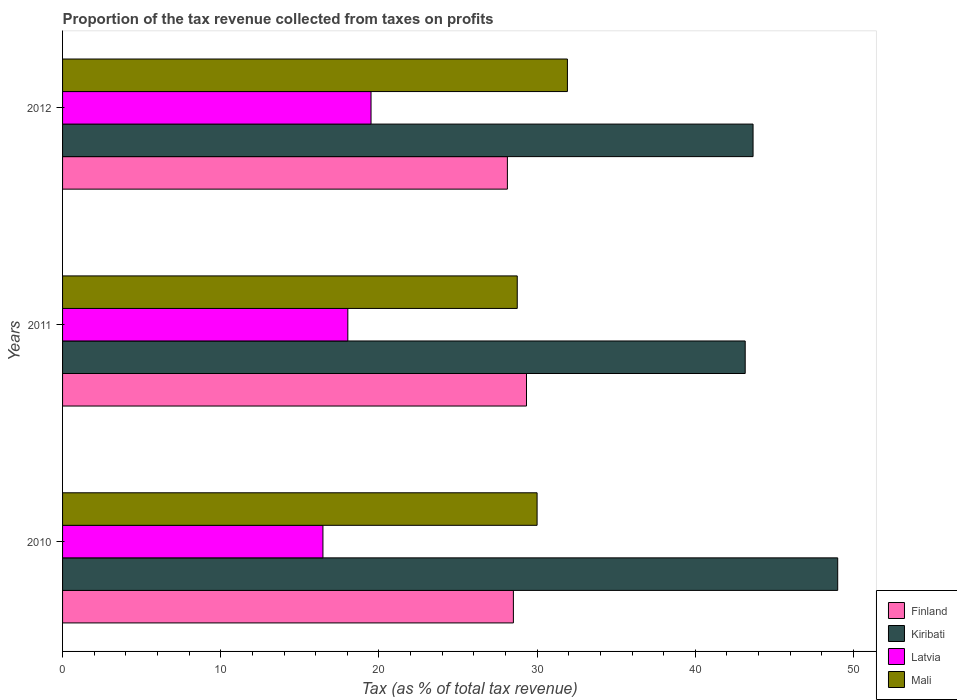How many groups of bars are there?
Provide a succinct answer. 3. How many bars are there on the 3rd tick from the top?
Provide a short and direct response. 4. What is the label of the 1st group of bars from the top?
Give a very brief answer. 2012. What is the proportion of the tax revenue collected in Latvia in 2010?
Offer a terse response. 16.46. Across all years, what is the maximum proportion of the tax revenue collected in Mali?
Offer a very short reply. 31.92. Across all years, what is the minimum proportion of the tax revenue collected in Finland?
Keep it short and to the point. 28.12. In which year was the proportion of the tax revenue collected in Finland maximum?
Your answer should be compact. 2011. In which year was the proportion of the tax revenue collected in Latvia minimum?
Offer a terse response. 2010. What is the total proportion of the tax revenue collected in Mali in the graph?
Make the answer very short. 90.66. What is the difference between the proportion of the tax revenue collected in Latvia in 2010 and that in 2011?
Provide a succinct answer. -1.57. What is the difference between the proportion of the tax revenue collected in Latvia in 2010 and the proportion of the tax revenue collected in Mali in 2012?
Your answer should be very brief. -15.46. What is the average proportion of the tax revenue collected in Finland per year?
Make the answer very short. 28.65. In the year 2011, what is the difference between the proportion of the tax revenue collected in Finland and proportion of the tax revenue collected in Kiribati?
Provide a succinct answer. -13.83. What is the ratio of the proportion of the tax revenue collected in Latvia in 2010 to that in 2011?
Your answer should be compact. 0.91. What is the difference between the highest and the second highest proportion of the tax revenue collected in Mali?
Offer a terse response. 1.92. What is the difference between the highest and the lowest proportion of the tax revenue collected in Finland?
Your answer should be compact. 1.21. In how many years, is the proportion of the tax revenue collected in Kiribati greater than the average proportion of the tax revenue collected in Kiribati taken over all years?
Your response must be concise. 1. Is the sum of the proportion of the tax revenue collected in Kiribati in 2011 and 2012 greater than the maximum proportion of the tax revenue collected in Mali across all years?
Your answer should be very brief. Yes. Is it the case that in every year, the sum of the proportion of the tax revenue collected in Kiribati and proportion of the tax revenue collected in Latvia is greater than the sum of proportion of the tax revenue collected in Mali and proportion of the tax revenue collected in Finland?
Offer a terse response. No. What does the 4th bar from the top in 2012 represents?
Your answer should be very brief. Finland. What does the 2nd bar from the bottom in 2010 represents?
Provide a short and direct response. Kiribati. Is it the case that in every year, the sum of the proportion of the tax revenue collected in Finland and proportion of the tax revenue collected in Kiribati is greater than the proportion of the tax revenue collected in Mali?
Your response must be concise. Yes. How many bars are there?
Your response must be concise. 12. Are all the bars in the graph horizontal?
Your response must be concise. Yes. What is the difference between two consecutive major ticks on the X-axis?
Keep it short and to the point. 10. Does the graph contain any zero values?
Your response must be concise. No. How are the legend labels stacked?
Your response must be concise. Vertical. What is the title of the graph?
Your answer should be very brief. Proportion of the tax revenue collected from taxes on profits. Does "Aruba" appear as one of the legend labels in the graph?
Provide a succinct answer. No. What is the label or title of the X-axis?
Provide a short and direct response. Tax (as % of total tax revenue). What is the label or title of the Y-axis?
Provide a short and direct response. Years. What is the Tax (as % of total tax revenue) of Finland in 2010?
Provide a succinct answer. 28.5. What is the Tax (as % of total tax revenue) of Kiribati in 2010?
Make the answer very short. 49. What is the Tax (as % of total tax revenue) in Latvia in 2010?
Your answer should be compact. 16.46. What is the Tax (as % of total tax revenue) of Mali in 2010?
Your answer should be very brief. 30. What is the Tax (as % of total tax revenue) of Finland in 2011?
Keep it short and to the point. 29.33. What is the Tax (as % of total tax revenue) in Kiribati in 2011?
Keep it short and to the point. 43.16. What is the Tax (as % of total tax revenue) in Latvia in 2011?
Offer a terse response. 18.03. What is the Tax (as % of total tax revenue) in Mali in 2011?
Your response must be concise. 28.75. What is the Tax (as % of total tax revenue) of Finland in 2012?
Offer a very short reply. 28.12. What is the Tax (as % of total tax revenue) of Kiribati in 2012?
Provide a succinct answer. 43.65. What is the Tax (as % of total tax revenue) of Latvia in 2012?
Make the answer very short. 19.5. What is the Tax (as % of total tax revenue) of Mali in 2012?
Your answer should be very brief. 31.92. Across all years, what is the maximum Tax (as % of total tax revenue) of Finland?
Keep it short and to the point. 29.33. Across all years, what is the maximum Tax (as % of total tax revenue) of Kiribati?
Provide a succinct answer. 49. Across all years, what is the maximum Tax (as % of total tax revenue) in Latvia?
Ensure brevity in your answer.  19.5. Across all years, what is the maximum Tax (as % of total tax revenue) of Mali?
Provide a succinct answer. 31.92. Across all years, what is the minimum Tax (as % of total tax revenue) of Finland?
Your answer should be very brief. 28.12. Across all years, what is the minimum Tax (as % of total tax revenue) of Kiribati?
Offer a terse response. 43.16. Across all years, what is the minimum Tax (as % of total tax revenue) of Latvia?
Your response must be concise. 16.46. Across all years, what is the minimum Tax (as % of total tax revenue) of Mali?
Offer a very short reply. 28.75. What is the total Tax (as % of total tax revenue) of Finland in the graph?
Your response must be concise. 85.95. What is the total Tax (as % of total tax revenue) in Kiribati in the graph?
Ensure brevity in your answer.  135.81. What is the total Tax (as % of total tax revenue) of Latvia in the graph?
Offer a very short reply. 54. What is the total Tax (as % of total tax revenue) of Mali in the graph?
Keep it short and to the point. 90.66. What is the difference between the Tax (as % of total tax revenue) of Finland in 2010 and that in 2011?
Provide a succinct answer. -0.83. What is the difference between the Tax (as % of total tax revenue) in Kiribati in 2010 and that in 2011?
Provide a short and direct response. 5.85. What is the difference between the Tax (as % of total tax revenue) of Latvia in 2010 and that in 2011?
Your response must be concise. -1.57. What is the difference between the Tax (as % of total tax revenue) in Mali in 2010 and that in 2011?
Your answer should be very brief. 1.25. What is the difference between the Tax (as % of total tax revenue) in Finland in 2010 and that in 2012?
Your answer should be compact. 0.38. What is the difference between the Tax (as % of total tax revenue) in Kiribati in 2010 and that in 2012?
Your response must be concise. 5.35. What is the difference between the Tax (as % of total tax revenue) in Latvia in 2010 and that in 2012?
Your response must be concise. -3.04. What is the difference between the Tax (as % of total tax revenue) in Mali in 2010 and that in 2012?
Your answer should be very brief. -1.92. What is the difference between the Tax (as % of total tax revenue) of Finland in 2011 and that in 2012?
Offer a terse response. 1.21. What is the difference between the Tax (as % of total tax revenue) of Kiribati in 2011 and that in 2012?
Your response must be concise. -0.5. What is the difference between the Tax (as % of total tax revenue) in Latvia in 2011 and that in 2012?
Ensure brevity in your answer.  -1.47. What is the difference between the Tax (as % of total tax revenue) in Mali in 2011 and that in 2012?
Offer a terse response. -3.17. What is the difference between the Tax (as % of total tax revenue) of Finland in 2010 and the Tax (as % of total tax revenue) of Kiribati in 2011?
Your answer should be very brief. -14.65. What is the difference between the Tax (as % of total tax revenue) of Finland in 2010 and the Tax (as % of total tax revenue) of Latvia in 2011?
Provide a succinct answer. 10.47. What is the difference between the Tax (as % of total tax revenue) in Finland in 2010 and the Tax (as % of total tax revenue) in Mali in 2011?
Give a very brief answer. -0.24. What is the difference between the Tax (as % of total tax revenue) of Kiribati in 2010 and the Tax (as % of total tax revenue) of Latvia in 2011?
Ensure brevity in your answer.  30.97. What is the difference between the Tax (as % of total tax revenue) of Kiribati in 2010 and the Tax (as % of total tax revenue) of Mali in 2011?
Give a very brief answer. 20.26. What is the difference between the Tax (as % of total tax revenue) of Latvia in 2010 and the Tax (as % of total tax revenue) of Mali in 2011?
Provide a succinct answer. -12.28. What is the difference between the Tax (as % of total tax revenue) of Finland in 2010 and the Tax (as % of total tax revenue) of Kiribati in 2012?
Your answer should be very brief. -15.15. What is the difference between the Tax (as % of total tax revenue) of Finland in 2010 and the Tax (as % of total tax revenue) of Latvia in 2012?
Your answer should be very brief. 9. What is the difference between the Tax (as % of total tax revenue) in Finland in 2010 and the Tax (as % of total tax revenue) in Mali in 2012?
Offer a terse response. -3.42. What is the difference between the Tax (as % of total tax revenue) in Kiribati in 2010 and the Tax (as % of total tax revenue) in Latvia in 2012?
Give a very brief answer. 29.5. What is the difference between the Tax (as % of total tax revenue) of Kiribati in 2010 and the Tax (as % of total tax revenue) of Mali in 2012?
Offer a terse response. 17.09. What is the difference between the Tax (as % of total tax revenue) of Latvia in 2010 and the Tax (as % of total tax revenue) of Mali in 2012?
Give a very brief answer. -15.46. What is the difference between the Tax (as % of total tax revenue) of Finland in 2011 and the Tax (as % of total tax revenue) of Kiribati in 2012?
Offer a very short reply. -14.32. What is the difference between the Tax (as % of total tax revenue) of Finland in 2011 and the Tax (as % of total tax revenue) of Latvia in 2012?
Keep it short and to the point. 9.83. What is the difference between the Tax (as % of total tax revenue) in Finland in 2011 and the Tax (as % of total tax revenue) in Mali in 2012?
Provide a short and direct response. -2.59. What is the difference between the Tax (as % of total tax revenue) in Kiribati in 2011 and the Tax (as % of total tax revenue) in Latvia in 2012?
Offer a terse response. 23.66. What is the difference between the Tax (as % of total tax revenue) in Kiribati in 2011 and the Tax (as % of total tax revenue) in Mali in 2012?
Make the answer very short. 11.24. What is the difference between the Tax (as % of total tax revenue) of Latvia in 2011 and the Tax (as % of total tax revenue) of Mali in 2012?
Provide a succinct answer. -13.88. What is the average Tax (as % of total tax revenue) of Finland per year?
Offer a terse response. 28.65. What is the average Tax (as % of total tax revenue) of Kiribati per year?
Give a very brief answer. 45.27. What is the average Tax (as % of total tax revenue) of Latvia per year?
Offer a very short reply. 18. What is the average Tax (as % of total tax revenue) in Mali per year?
Your answer should be very brief. 30.22. In the year 2010, what is the difference between the Tax (as % of total tax revenue) of Finland and Tax (as % of total tax revenue) of Kiribati?
Your answer should be compact. -20.5. In the year 2010, what is the difference between the Tax (as % of total tax revenue) of Finland and Tax (as % of total tax revenue) of Latvia?
Offer a terse response. 12.04. In the year 2010, what is the difference between the Tax (as % of total tax revenue) in Finland and Tax (as % of total tax revenue) in Mali?
Your answer should be compact. -1.5. In the year 2010, what is the difference between the Tax (as % of total tax revenue) in Kiribati and Tax (as % of total tax revenue) in Latvia?
Give a very brief answer. 32.54. In the year 2010, what is the difference between the Tax (as % of total tax revenue) in Kiribati and Tax (as % of total tax revenue) in Mali?
Your answer should be compact. 19.01. In the year 2010, what is the difference between the Tax (as % of total tax revenue) of Latvia and Tax (as % of total tax revenue) of Mali?
Your answer should be very brief. -13.54. In the year 2011, what is the difference between the Tax (as % of total tax revenue) in Finland and Tax (as % of total tax revenue) in Kiribati?
Your response must be concise. -13.83. In the year 2011, what is the difference between the Tax (as % of total tax revenue) of Finland and Tax (as % of total tax revenue) of Latvia?
Provide a succinct answer. 11.3. In the year 2011, what is the difference between the Tax (as % of total tax revenue) of Finland and Tax (as % of total tax revenue) of Mali?
Give a very brief answer. 0.59. In the year 2011, what is the difference between the Tax (as % of total tax revenue) in Kiribati and Tax (as % of total tax revenue) in Latvia?
Offer a terse response. 25.12. In the year 2011, what is the difference between the Tax (as % of total tax revenue) in Kiribati and Tax (as % of total tax revenue) in Mali?
Offer a very short reply. 14.41. In the year 2011, what is the difference between the Tax (as % of total tax revenue) of Latvia and Tax (as % of total tax revenue) of Mali?
Provide a short and direct response. -10.71. In the year 2012, what is the difference between the Tax (as % of total tax revenue) in Finland and Tax (as % of total tax revenue) in Kiribati?
Keep it short and to the point. -15.53. In the year 2012, what is the difference between the Tax (as % of total tax revenue) in Finland and Tax (as % of total tax revenue) in Latvia?
Your answer should be compact. 8.62. In the year 2012, what is the difference between the Tax (as % of total tax revenue) in Finland and Tax (as % of total tax revenue) in Mali?
Offer a very short reply. -3.8. In the year 2012, what is the difference between the Tax (as % of total tax revenue) in Kiribati and Tax (as % of total tax revenue) in Latvia?
Ensure brevity in your answer.  24.15. In the year 2012, what is the difference between the Tax (as % of total tax revenue) of Kiribati and Tax (as % of total tax revenue) of Mali?
Keep it short and to the point. 11.74. In the year 2012, what is the difference between the Tax (as % of total tax revenue) of Latvia and Tax (as % of total tax revenue) of Mali?
Your answer should be compact. -12.42. What is the ratio of the Tax (as % of total tax revenue) in Finland in 2010 to that in 2011?
Your response must be concise. 0.97. What is the ratio of the Tax (as % of total tax revenue) in Kiribati in 2010 to that in 2011?
Ensure brevity in your answer.  1.14. What is the ratio of the Tax (as % of total tax revenue) of Latvia in 2010 to that in 2011?
Provide a succinct answer. 0.91. What is the ratio of the Tax (as % of total tax revenue) of Mali in 2010 to that in 2011?
Make the answer very short. 1.04. What is the ratio of the Tax (as % of total tax revenue) in Finland in 2010 to that in 2012?
Provide a succinct answer. 1.01. What is the ratio of the Tax (as % of total tax revenue) in Kiribati in 2010 to that in 2012?
Offer a very short reply. 1.12. What is the ratio of the Tax (as % of total tax revenue) in Latvia in 2010 to that in 2012?
Provide a short and direct response. 0.84. What is the ratio of the Tax (as % of total tax revenue) in Mali in 2010 to that in 2012?
Provide a succinct answer. 0.94. What is the ratio of the Tax (as % of total tax revenue) in Finland in 2011 to that in 2012?
Keep it short and to the point. 1.04. What is the ratio of the Tax (as % of total tax revenue) of Latvia in 2011 to that in 2012?
Make the answer very short. 0.92. What is the ratio of the Tax (as % of total tax revenue) of Mali in 2011 to that in 2012?
Provide a succinct answer. 0.9. What is the difference between the highest and the second highest Tax (as % of total tax revenue) of Finland?
Make the answer very short. 0.83. What is the difference between the highest and the second highest Tax (as % of total tax revenue) of Kiribati?
Ensure brevity in your answer.  5.35. What is the difference between the highest and the second highest Tax (as % of total tax revenue) in Latvia?
Ensure brevity in your answer.  1.47. What is the difference between the highest and the second highest Tax (as % of total tax revenue) in Mali?
Offer a terse response. 1.92. What is the difference between the highest and the lowest Tax (as % of total tax revenue) of Finland?
Offer a very short reply. 1.21. What is the difference between the highest and the lowest Tax (as % of total tax revenue) in Kiribati?
Your answer should be compact. 5.85. What is the difference between the highest and the lowest Tax (as % of total tax revenue) in Latvia?
Your answer should be very brief. 3.04. What is the difference between the highest and the lowest Tax (as % of total tax revenue) in Mali?
Your response must be concise. 3.17. 